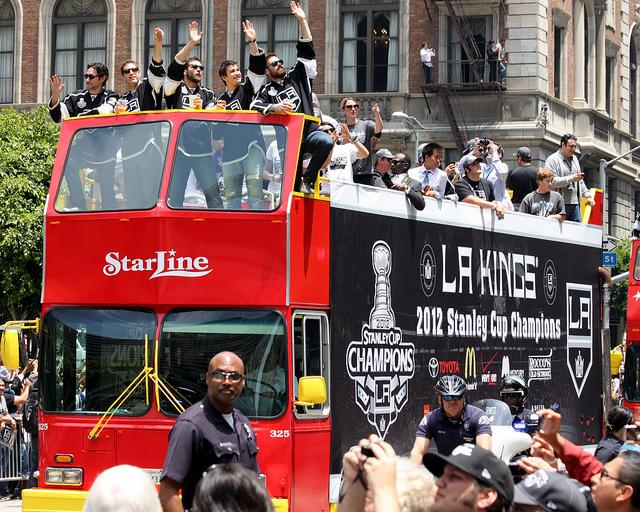What kind of team is this celebrating? Please explain your reasoning. nhl hockey. Stanley cup is for hockey. 